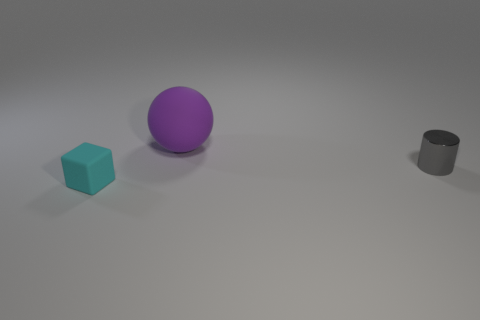Can you tell me the shapes of the objects and their arrangement in the image? Certainly! In the image, we observe three geometric shapes: a cube on the left, a sphere in the center, and a cylinder on the right. The cube and the cylinder are positioned closer to the camera compared to the sphere, which is situated between them but set slightly back. 